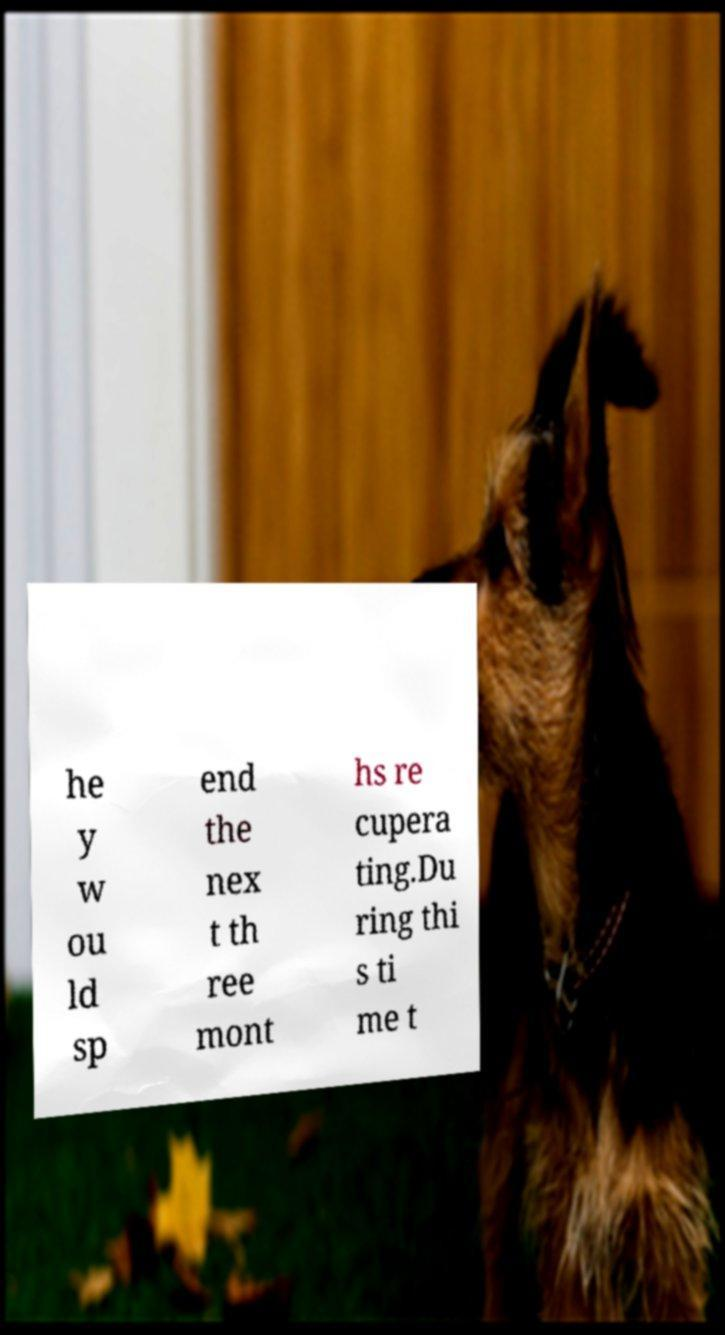Please identify and transcribe the text found in this image. he y w ou ld sp end the nex t th ree mont hs re cupera ting.Du ring thi s ti me t 